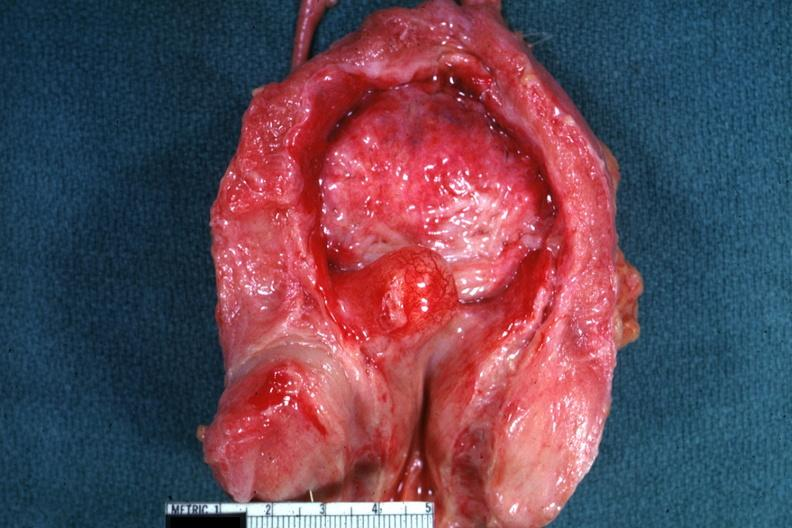s hyperplasia present?
Answer the question using a single word or phrase. Yes 